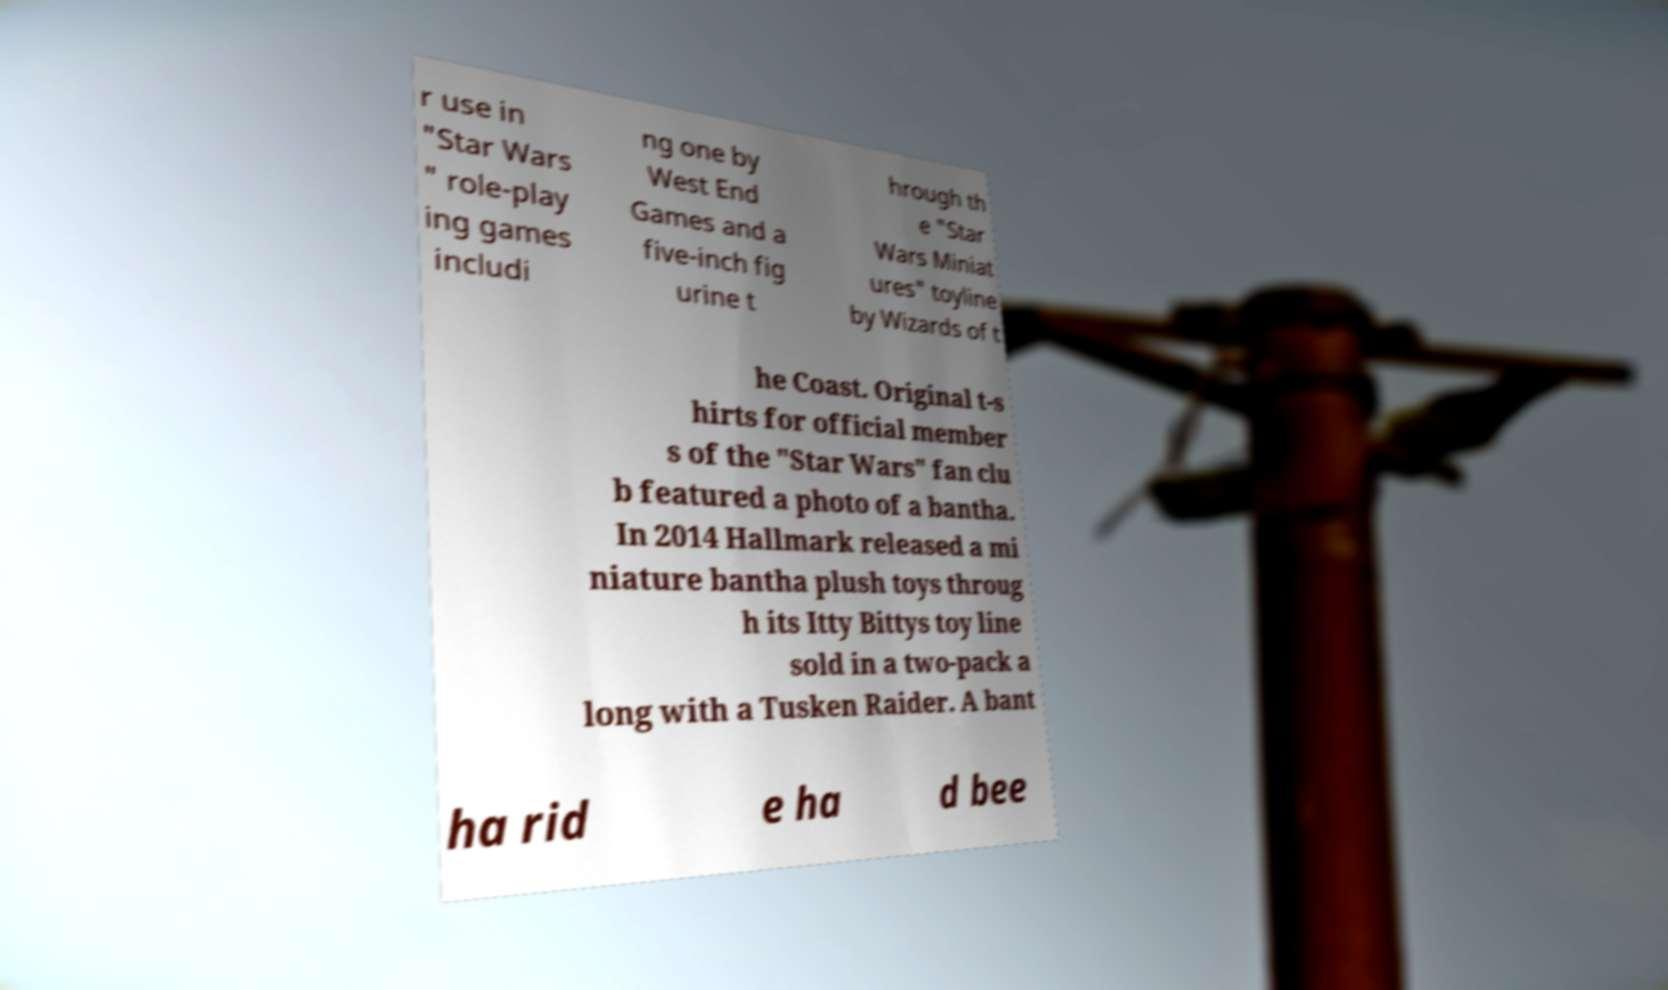Could you extract and type out the text from this image? r use in "Star Wars " role-play ing games includi ng one by West End Games and a five-inch fig urine t hrough th e "Star Wars Miniat ures" toyline by Wizards of t he Coast. Original t-s hirts for official member s of the "Star Wars" fan clu b featured a photo of a bantha. In 2014 Hallmark released a mi niature bantha plush toys throug h its Itty Bittys toy line sold in a two-pack a long with a Tusken Raider. A bant ha rid e ha d bee 